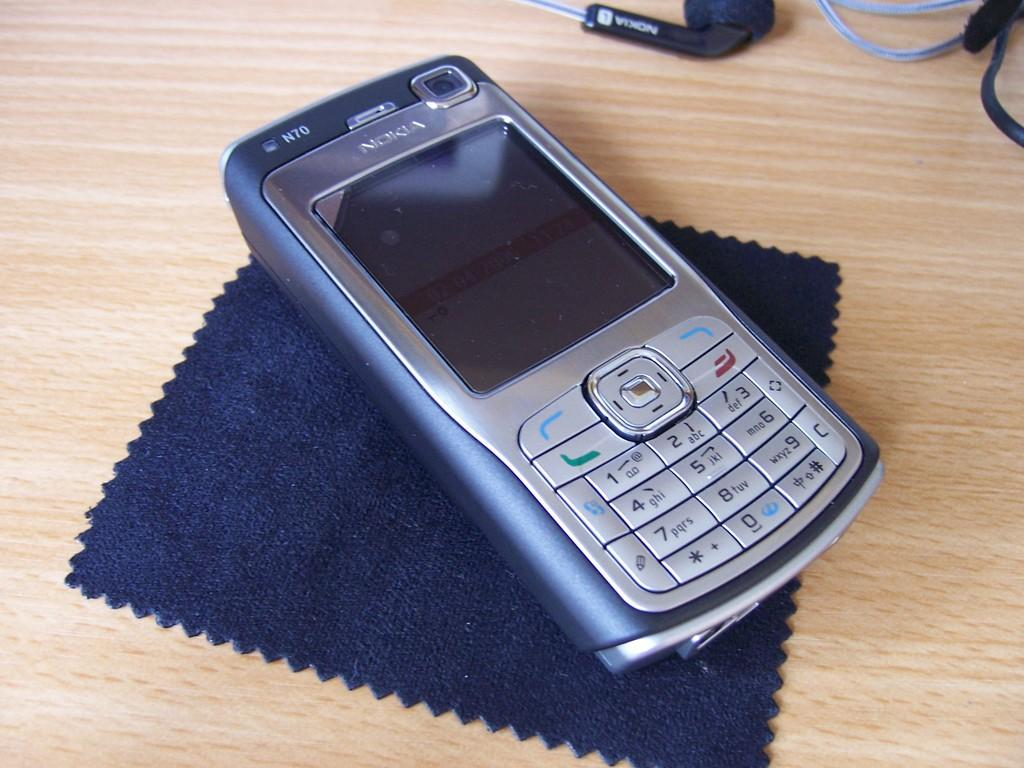Provide a one-sentence caption for the provided image. A Nokia N70 mobile phone sitting on a desk. 